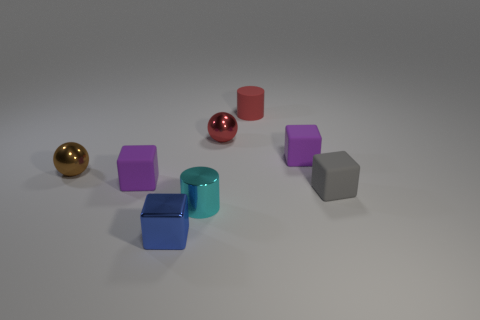Add 2 brown shiny cylinders. How many objects exist? 10 Subtract all gray cubes. How many cubes are left? 3 Subtract all tiny gray rubber cubes. How many cubes are left? 3 Subtract all cyan cubes. Subtract all purple spheres. How many cubes are left? 4 Subtract all spheres. How many objects are left? 6 Subtract all tiny rubber cubes. Subtract all rubber objects. How many objects are left? 1 Add 5 red metallic balls. How many red metallic balls are left? 6 Add 1 small gray things. How many small gray things exist? 2 Subtract 1 red spheres. How many objects are left? 7 